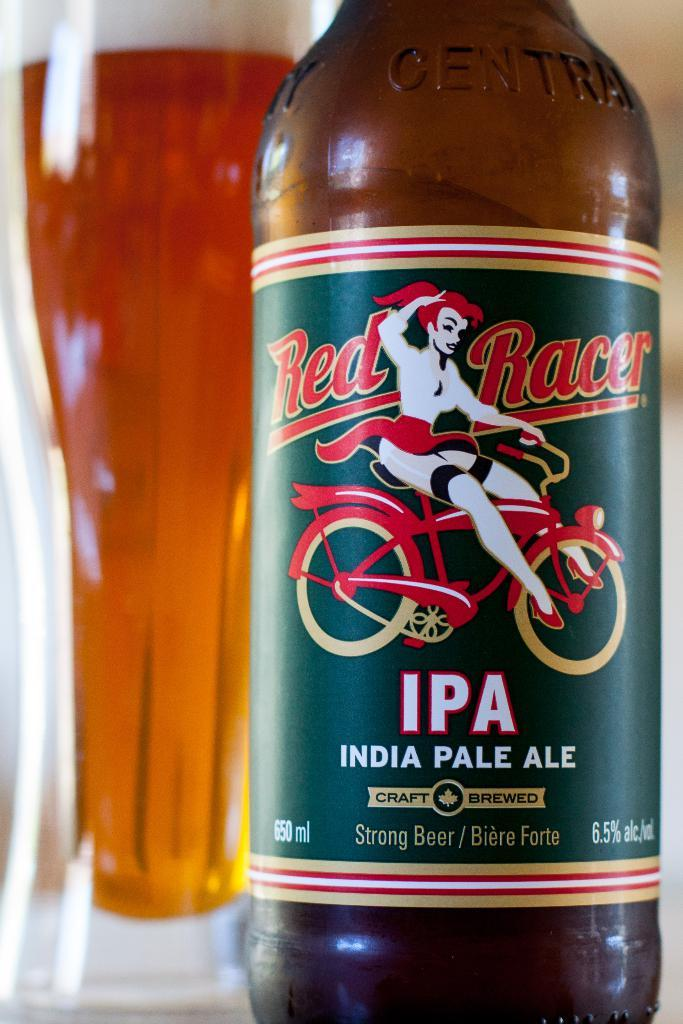<image>
Relay a brief, clear account of the picture shown. India Pale Ale brewed beer with a glass behind it 